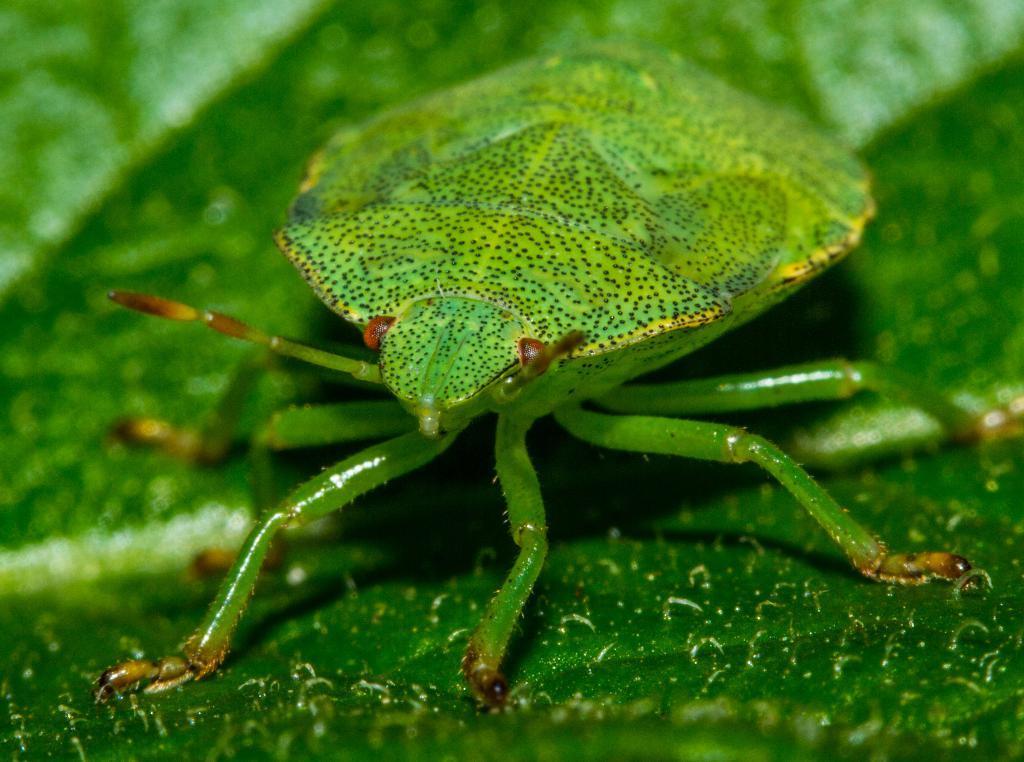Could you give a brief overview of what you see in this image? In this image I can see an insect on a leaf. This insect is in green color. 